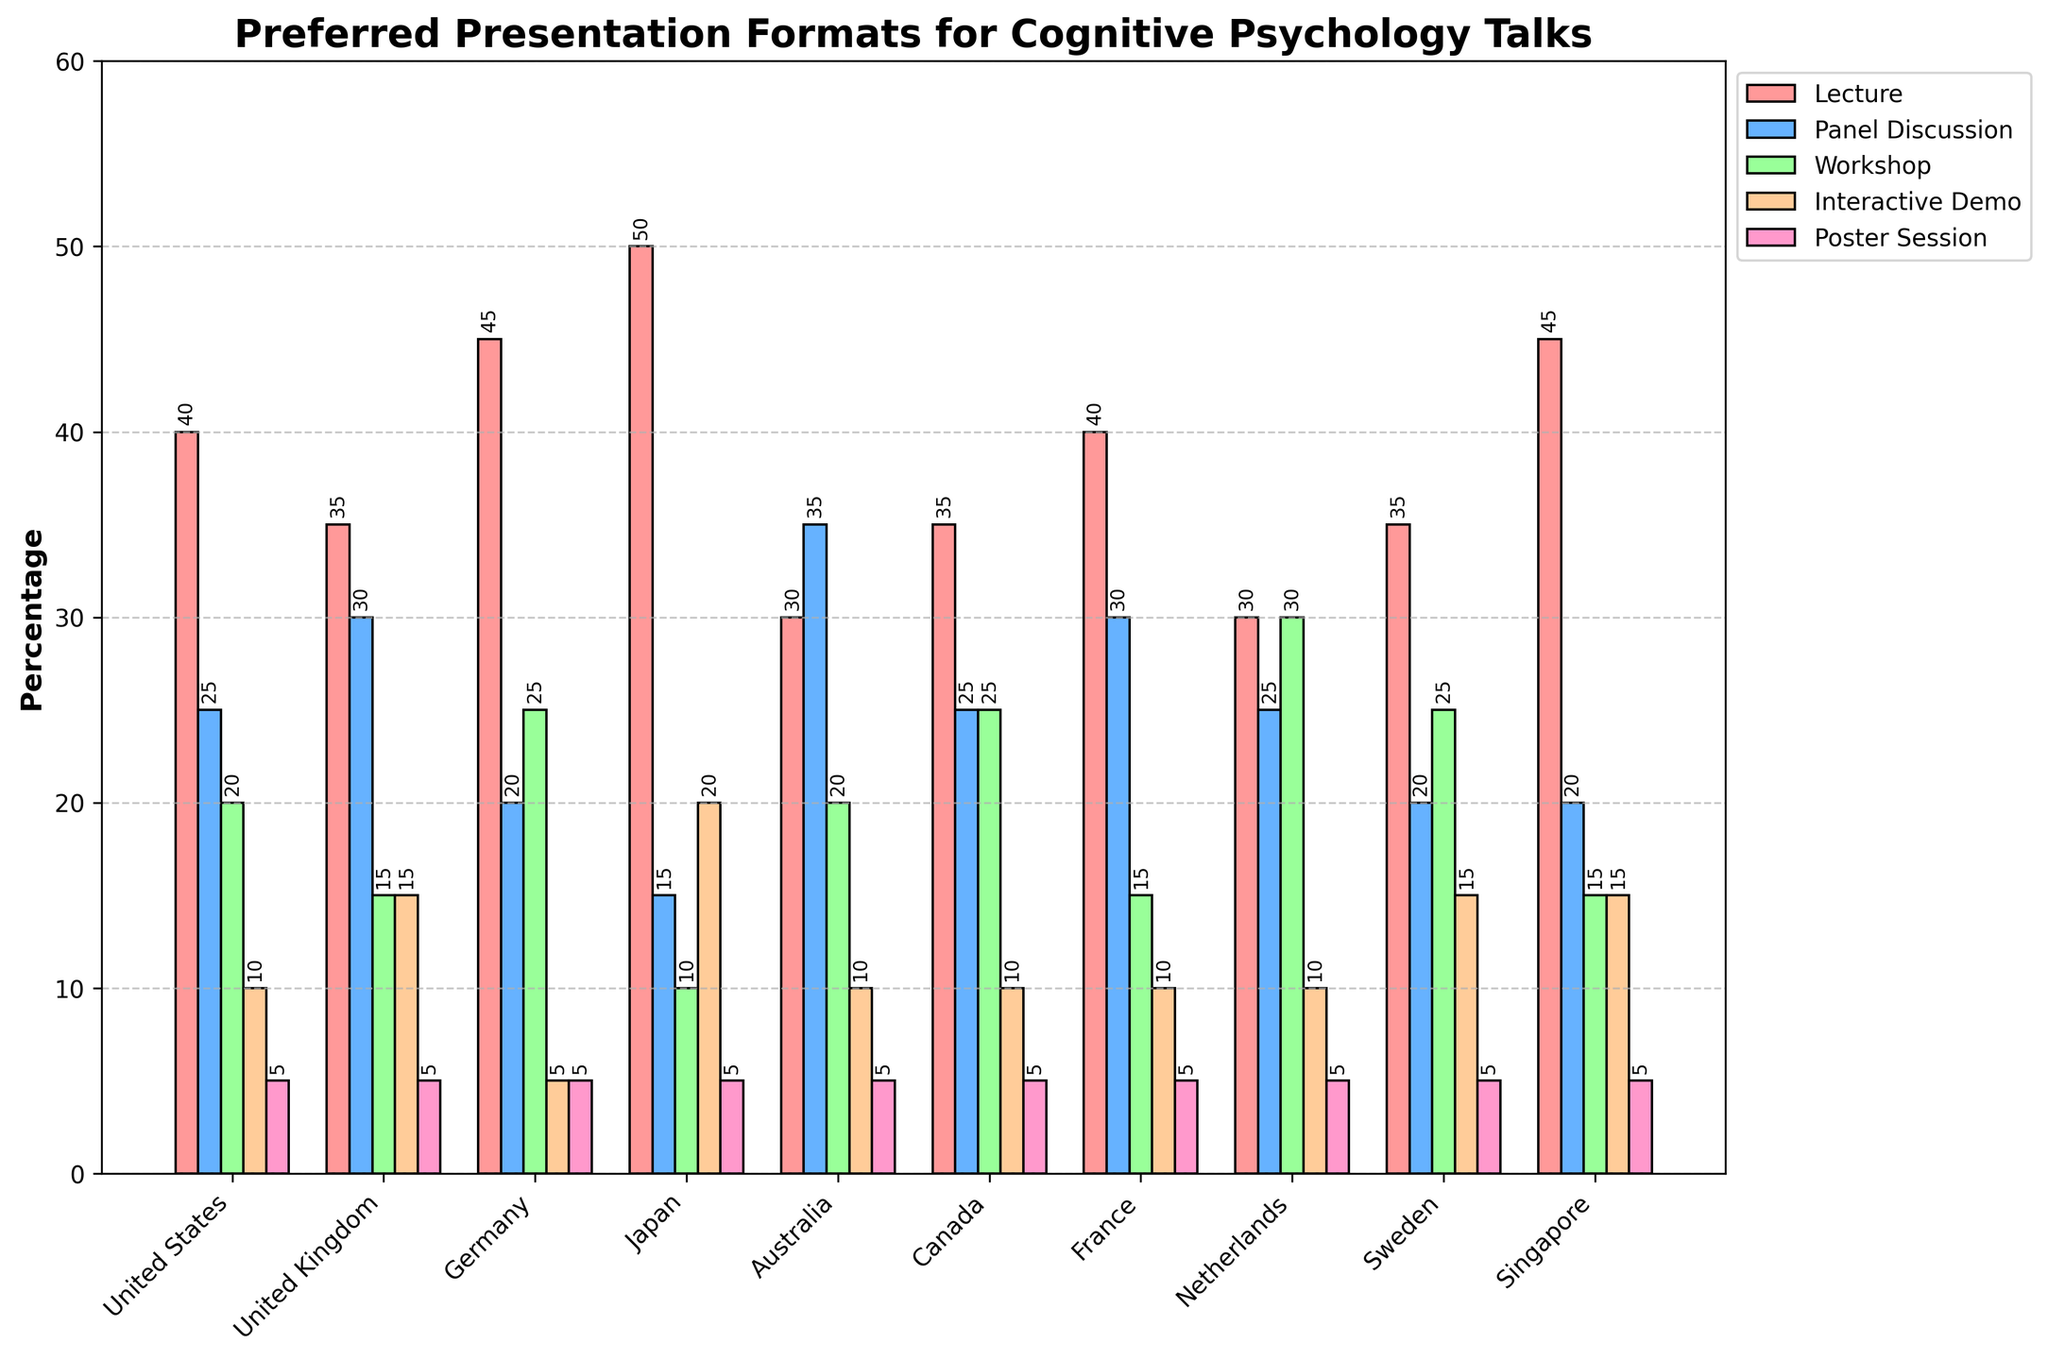What's the most preferred presentation format in Japan? To find the most preferred presentation format in Japan, look for the highest bar representing Japan's data. The Lecture format has the highest percentage at 50%.
Answer: Lecture How many countries have the Poster Session as their least preferred format? To find this, check if the Poster Session bar is the smallest in each country. All countries have the Poster Session as the least preferred format with a constant 5%.
Answer: 10 Which country prefers Workshops the most? Check the values of the Workshop format for each country and find the highest one. Germany has the highest preference for Workshops at 25%.
Answer: Germany Compare the preference for Panel Discussions between the United Kingdom and the United States. Which one has a higher percentage? Look at the Panel Discussion bars for the United Kingdom and the United States. The United Kingdom has 30%, and the United States has 25%. Thus, the United Kingdom prefers Panel Discussions more.
Answer: United Kingdom What is the average preference for Interactive Demos across all countries? To calculate this, sum up the preference percentages for Interactive Demos in all countries and divide by the number of countries. The values are 10, 15, 5, 20, 10, 10, 10, 10, 15, 15. Sum: 120, Number of countries: 10, so 120/10 = 12%.
Answer: 12 United States: 40 - 25
Answer: = 15 United Kingdom: 35 - 30
Answer: = 5 Germany: 45 - 20
Answer: = 25 Japan: 50 - 15
Answer: = 35 Australia: 30 - 35
Answer: = 5 Canada: 35 - 25
Answer: = 10 France: 40 - 30
Answer: = 10 Netherlands: 30 - 25
Answer: = 5 Sweden: 35 - 20
Answer: = 15 Singapore: 45 - 20
Answer: = 25 What is the total percentage for all preferred formats in Australia? Sum all the preferred format percentages listed for Australia: 30 (Lecture) + 35 (Panel Discussion) + 20 (Workshop) + 10 (Interactive Demo) + 5 (Poster Session) = 100%.
Answer: 100 